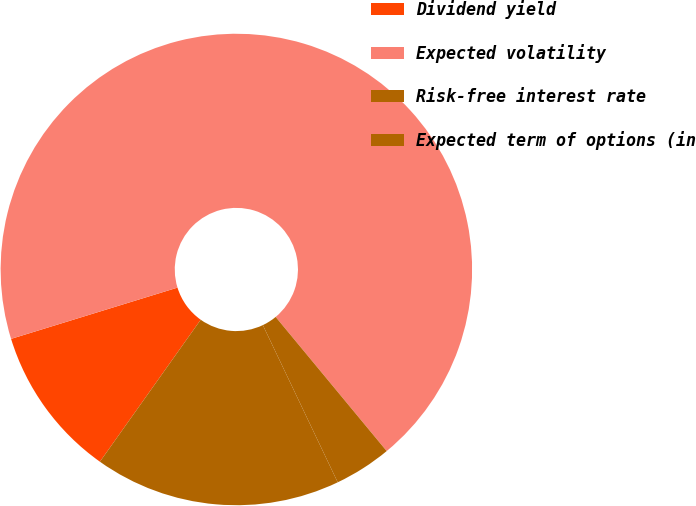<chart> <loc_0><loc_0><loc_500><loc_500><pie_chart><fcel>Dividend yield<fcel>Expected volatility<fcel>Risk-free interest rate<fcel>Expected term of options (in<nl><fcel>10.42%<fcel>68.75%<fcel>3.93%<fcel>16.9%<nl></chart> 